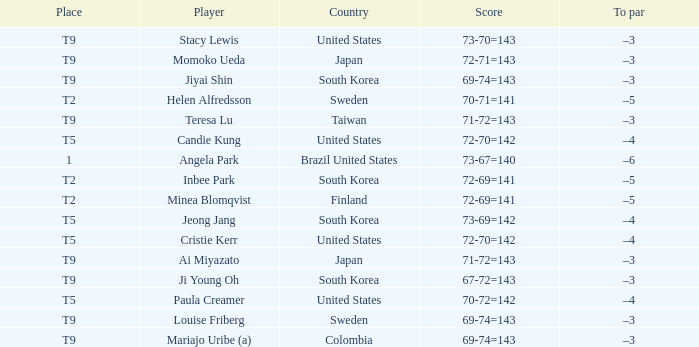From which country did the t9-ranked player jiyai shin hail? South Korea. 